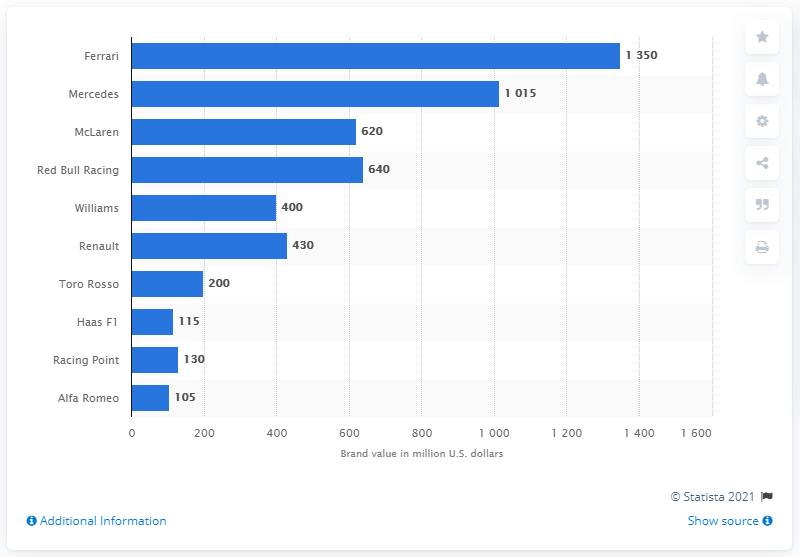Identify some key points in this picture. Ferrari's team value in dollars in 2018 was estimated to be 1,350. 